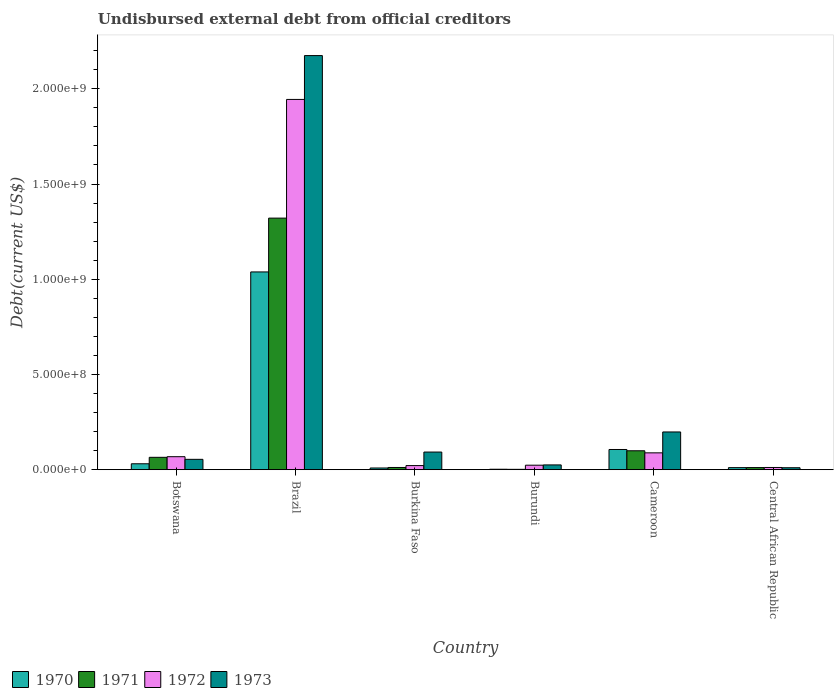How many groups of bars are there?
Offer a very short reply. 6. How many bars are there on the 1st tick from the left?
Give a very brief answer. 4. How many bars are there on the 3rd tick from the right?
Offer a very short reply. 4. What is the label of the 6th group of bars from the left?
Give a very brief answer. Central African Republic. In how many cases, is the number of bars for a given country not equal to the number of legend labels?
Provide a succinct answer. 0. What is the total debt in 1971 in Burundi?
Keep it short and to the point. 1.93e+06. Across all countries, what is the maximum total debt in 1971?
Your response must be concise. 1.32e+09. Across all countries, what is the minimum total debt in 1972?
Give a very brief answer. 1.16e+07. In which country was the total debt in 1971 maximum?
Your response must be concise. Brazil. In which country was the total debt in 1970 minimum?
Offer a very short reply. Burundi. What is the total total debt in 1972 in the graph?
Keep it short and to the point. 2.16e+09. What is the difference between the total debt in 1971 in Brazil and that in Cameroon?
Keep it short and to the point. 1.22e+09. What is the difference between the total debt in 1972 in Central African Republic and the total debt in 1973 in Burundi?
Give a very brief answer. -1.35e+07. What is the average total debt in 1973 per country?
Provide a short and direct response. 4.26e+08. What is the difference between the total debt of/in 1971 and total debt of/in 1973 in Burundi?
Keep it short and to the point. -2.32e+07. What is the ratio of the total debt in 1972 in Burkina Faso to that in Burundi?
Keep it short and to the point. 0.91. What is the difference between the highest and the second highest total debt in 1970?
Your response must be concise. 9.32e+08. What is the difference between the highest and the lowest total debt in 1971?
Your answer should be very brief. 1.32e+09. Is it the case that in every country, the sum of the total debt in 1970 and total debt in 1973 is greater than the sum of total debt in 1971 and total debt in 1972?
Give a very brief answer. No. Is it the case that in every country, the sum of the total debt in 1970 and total debt in 1973 is greater than the total debt in 1972?
Your response must be concise. Yes. How many bars are there?
Provide a succinct answer. 24. What is the difference between two consecutive major ticks on the Y-axis?
Offer a very short reply. 5.00e+08. Are the values on the major ticks of Y-axis written in scientific E-notation?
Your answer should be very brief. Yes. How many legend labels are there?
Give a very brief answer. 4. How are the legend labels stacked?
Provide a succinct answer. Horizontal. What is the title of the graph?
Offer a terse response. Undisbursed external debt from official creditors. Does "2008" appear as one of the legend labels in the graph?
Your response must be concise. No. What is the label or title of the X-axis?
Make the answer very short. Country. What is the label or title of the Y-axis?
Provide a short and direct response. Debt(current US$). What is the Debt(current US$) in 1970 in Botswana?
Provide a short and direct response. 3.11e+07. What is the Debt(current US$) in 1971 in Botswana?
Provide a succinct answer. 6.50e+07. What is the Debt(current US$) in 1972 in Botswana?
Ensure brevity in your answer.  6.83e+07. What is the Debt(current US$) of 1973 in Botswana?
Ensure brevity in your answer.  5.44e+07. What is the Debt(current US$) in 1970 in Brazil?
Provide a succinct answer. 1.04e+09. What is the Debt(current US$) of 1971 in Brazil?
Provide a short and direct response. 1.32e+09. What is the Debt(current US$) in 1972 in Brazil?
Ensure brevity in your answer.  1.94e+09. What is the Debt(current US$) of 1973 in Brazil?
Offer a terse response. 2.17e+09. What is the Debt(current US$) in 1970 in Burkina Faso?
Your answer should be very brief. 8.96e+06. What is the Debt(current US$) in 1971 in Burkina Faso?
Give a very brief answer. 1.16e+07. What is the Debt(current US$) of 1972 in Burkina Faso?
Ensure brevity in your answer.  2.16e+07. What is the Debt(current US$) in 1973 in Burkina Faso?
Provide a succinct answer. 9.26e+07. What is the Debt(current US$) of 1970 in Burundi?
Your answer should be compact. 2.42e+06. What is the Debt(current US$) of 1971 in Burundi?
Your answer should be compact. 1.93e+06. What is the Debt(current US$) in 1972 in Burundi?
Provide a succinct answer. 2.37e+07. What is the Debt(current US$) in 1973 in Burundi?
Ensure brevity in your answer.  2.51e+07. What is the Debt(current US$) in 1970 in Cameroon?
Offer a terse response. 1.06e+08. What is the Debt(current US$) in 1971 in Cameroon?
Give a very brief answer. 9.94e+07. What is the Debt(current US$) of 1972 in Cameroon?
Keep it short and to the point. 8.84e+07. What is the Debt(current US$) in 1973 in Cameroon?
Give a very brief answer. 1.98e+08. What is the Debt(current US$) of 1970 in Central African Republic?
Your answer should be very brief. 1.08e+07. What is the Debt(current US$) in 1971 in Central African Republic?
Ensure brevity in your answer.  1.12e+07. What is the Debt(current US$) of 1972 in Central African Republic?
Your answer should be compact. 1.16e+07. What is the Debt(current US$) of 1973 in Central African Republic?
Give a very brief answer. 1.04e+07. Across all countries, what is the maximum Debt(current US$) of 1970?
Keep it short and to the point. 1.04e+09. Across all countries, what is the maximum Debt(current US$) in 1971?
Offer a terse response. 1.32e+09. Across all countries, what is the maximum Debt(current US$) in 1972?
Give a very brief answer. 1.94e+09. Across all countries, what is the maximum Debt(current US$) of 1973?
Your answer should be very brief. 2.17e+09. Across all countries, what is the minimum Debt(current US$) of 1970?
Make the answer very short. 2.42e+06. Across all countries, what is the minimum Debt(current US$) in 1971?
Provide a succinct answer. 1.93e+06. Across all countries, what is the minimum Debt(current US$) in 1972?
Provide a succinct answer. 1.16e+07. Across all countries, what is the minimum Debt(current US$) of 1973?
Keep it short and to the point. 1.04e+07. What is the total Debt(current US$) of 1970 in the graph?
Your answer should be compact. 1.20e+09. What is the total Debt(current US$) of 1971 in the graph?
Provide a short and direct response. 1.51e+09. What is the total Debt(current US$) in 1972 in the graph?
Keep it short and to the point. 2.16e+09. What is the total Debt(current US$) of 1973 in the graph?
Make the answer very short. 2.55e+09. What is the difference between the Debt(current US$) in 1970 in Botswana and that in Brazil?
Provide a short and direct response. -1.01e+09. What is the difference between the Debt(current US$) of 1971 in Botswana and that in Brazil?
Give a very brief answer. -1.26e+09. What is the difference between the Debt(current US$) of 1972 in Botswana and that in Brazil?
Provide a succinct answer. -1.88e+09. What is the difference between the Debt(current US$) in 1973 in Botswana and that in Brazil?
Offer a very short reply. -2.12e+09. What is the difference between the Debt(current US$) in 1970 in Botswana and that in Burkina Faso?
Your answer should be very brief. 2.21e+07. What is the difference between the Debt(current US$) in 1971 in Botswana and that in Burkina Faso?
Give a very brief answer. 5.34e+07. What is the difference between the Debt(current US$) of 1972 in Botswana and that in Burkina Faso?
Your answer should be very brief. 4.67e+07. What is the difference between the Debt(current US$) of 1973 in Botswana and that in Burkina Faso?
Keep it short and to the point. -3.82e+07. What is the difference between the Debt(current US$) in 1970 in Botswana and that in Burundi?
Offer a terse response. 2.86e+07. What is the difference between the Debt(current US$) in 1971 in Botswana and that in Burundi?
Give a very brief answer. 6.31e+07. What is the difference between the Debt(current US$) in 1972 in Botswana and that in Burundi?
Provide a short and direct response. 4.46e+07. What is the difference between the Debt(current US$) in 1973 in Botswana and that in Burundi?
Keep it short and to the point. 2.93e+07. What is the difference between the Debt(current US$) in 1970 in Botswana and that in Cameroon?
Provide a short and direct response. -7.50e+07. What is the difference between the Debt(current US$) of 1971 in Botswana and that in Cameroon?
Your response must be concise. -3.44e+07. What is the difference between the Debt(current US$) in 1972 in Botswana and that in Cameroon?
Give a very brief answer. -2.02e+07. What is the difference between the Debt(current US$) of 1973 in Botswana and that in Cameroon?
Give a very brief answer. -1.44e+08. What is the difference between the Debt(current US$) of 1970 in Botswana and that in Central African Republic?
Offer a very short reply. 2.02e+07. What is the difference between the Debt(current US$) in 1971 in Botswana and that in Central African Republic?
Your answer should be compact. 5.38e+07. What is the difference between the Debt(current US$) in 1972 in Botswana and that in Central African Republic?
Your answer should be compact. 5.66e+07. What is the difference between the Debt(current US$) of 1973 in Botswana and that in Central African Republic?
Your response must be concise. 4.40e+07. What is the difference between the Debt(current US$) in 1970 in Brazil and that in Burkina Faso?
Your response must be concise. 1.03e+09. What is the difference between the Debt(current US$) in 1971 in Brazil and that in Burkina Faso?
Offer a very short reply. 1.31e+09. What is the difference between the Debt(current US$) of 1972 in Brazil and that in Burkina Faso?
Offer a terse response. 1.92e+09. What is the difference between the Debt(current US$) of 1973 in Brazil and that in Burkina Faso?
Offer a terse response. 2.08e+09. What is the difference between the Debt(current US$) in 1970 in Brazil and that in Burundi?
Your answer should be compact. 1.04e+09. What is the difference between the Debt(current US$) of 1971 in Brazil and that in Burundi?
Provide a succinct answer. 1.32e+09. What is the difference between the Debt(current US$) of 1972 in Brazil and that in Burundi?
Your answer should be compact. 1.92e+09. What is the difference between the Debt(current US$) of 1973 in Brazil and that in Burundi?
Your answer should be very brief. 2.15e+09. What is the difference between the Debt(current US$) of 1970 in Brazil and that in Cameroon?
Offer a very short reply. 9.32e+08. What is the difference between the Debt(current US$) in 1971 in Brazil and that in Cameroon?
Give a very brief answer. 1.22e+09. What is the difference between the Debt(current US$) of 1972 in Brazil and that in Cameroon?
Your answer should be very brief. 1.86e+09. What is the difference between the Debt(current US$) of 1973 in Brazil and that in Cameroon?
Your answer should be compact. 1.98e+09. What is the difference between the Debt(current US$) of 1970 in Brazil and that in Central African Republic?
Make the answer very short. 1.03e+09. What is the difference between the Debt(current US$) of 1971 in Brazil and that in Central African Republic?
Your answer should be very brief. 1.31e+09. What is the difference between the Debt(current US$) of 1972 in Brazil and that in Central African Republic?
Give a very brief answer. 1.93e+09. What is the difference between the Debt(current US$) of 1973 in Brazil and that in Central African Republic?
Your answer should be compact. 2.16e+09. What is the difference between the Debt(current US$) in 1970 in Burkina Faso and that in Burundi?
Offer a very short reply. 6.54e+06. What is the difference between the Debt(current US$) in 1971 in Burkina Faso and that in Burundi?
Your response must be concise. 9.71e+06. What is the difference between the Debt(current US$) in 1972 in Burkina Faso and that in Burundi?
Keep it short and to the point. -2.08e+06. What is the difference between the Debt(current US$) of 1973 in Burkina Faso and that in Burundi?
Your answer should be very brief. 6.75e+07. What is the difference between the Debt(current US$) in 1970 in Burkina Faso and that in Cameroon?
Provide a short and direct response. -9.71e+07. What is the difference between the Debt(current US$) in 1971 in Burkina Faso and that in Cameroon?
Offer a very short reply. -8.77e+07. What is the difference between the Debt(current US$) in 1972 in Burkina Faso and that in Cameroon?
Your answer should be compact. -6.69e+07. What is the difference between the Debt(current US$) of 1973 in Burkina Faso and that in Cameroon?
Provide a succinct answer. -1.06e+08. What is the difference between the Debt(current US$) in 1970 in Burkina Faso and that in Central African Republic?
Keep it short and to the point. -1.89e+06. What is the difference between the Debt(current US$) of 1972 in Burkina Faso and that in Central African Republic?
Ensure brevity in your answer.  9.94e+06. What is the difference between the Debt(current US$) of 1973 in Burkina Faso and that in Central African Republic?
Make the answer very short. 8.22e+07. What is the difference between the Debt(current US$) of 1970 in Burundi and that in Cameroon?
Offer a very short reply. -1.04e+08. What is the difference between the Debt(current US$) in 1971 in Burundi and that in Cameroon?
Provide a succinct answer. -9.74e+07. What is the difference between the Debt(current US$) of 1972 in Burundi and that in Cameroon?
Your answer should be compact. -6.48e+07. What is the difference between the Debt(current US$) of 1973 in Burundi and that in Cameroon?
Offer a terse response. -1.73e+08. What is the difference between the Debt(current US$) in 1970 in Burundi and that in Central African Republic?
Provide a succinct answer. -8.42e+06. What is the difference between the Debt(current US$) in 1971 in Burundi and that in Central African Republic?
Provide a short and direct response. -9.26e+06. What is the difference between the Debt(current US$) in 1972 in Burundi and that in Central African Republic?
Your response must be concise. 1.20e+07. What is the difference between the Debt(current US$) of 1973 in Burundi and that in Central African Republic?
Keep it short and to the point. 1.47e+07. What is the difference between the Debt(current US$) of 1970 in Cameroon and that in Central African Republic?
Offer a very short reply. 9.52e+07. What is the difference between the Debt(current US$) in 1971 in Cameroon and that in Central African Republic?
Offer a terse response. 8.82e+07. What is the difference between the Debt(current US$) of 1972 in Cameroon and that in Central African Republic?
Offer a terse response. 7.68e+07. What is the difference between the Debt(current US$) in 1973 in Cameroon and that in Central African Republic?
Your response must be concise. 1.88e+08. What is the difference between the Debt(current US$) of 1970 in Botswana and the Debt(current US$) of 1971 in Brazil?
Make the answer very short. -1.29e+09. What is the difference between the Debt(current US$) in 1970 in Botswana and the Debt(current US$) in 1972 in Brazil?
Offer a terse response. -1.91e+09. What is the difference between the Debt(current US$) of 1970 in Botswana and the Debt(current US$) of 1973 in Brazil?
Offer a very short reply. -2.14e+09. What is the difference between the Debt(current US$) in 1971 in Botswana and the Debt(current US$) in 1972 in Brazil?
Make the answer very short. -1.88e+09. What is the difference between the Debt(current US$) in 1971 in Botswana and the Debt(current US$) in 1973 in Brazil?
Ensure brevity in your answer.  -2.11e+09. What is the difference between the Debt(current US$) in 1972 in Botswana and the Debt(current US$) in 1973 in Brazil?
Offer a very short reply. -2.11e+09. What is the difference between the Debt(current US$) in 1970 in Botswana and the Debt(current US$) in 1971 in Burkina Faso?
Your answer should be compact. 1.94e+07. What is the difference between the Debt(current US$) in 1970 in Botswana and the Debt(current US$) in 1972 in Burkina Faso?
Your answer should be very brief. 9.50e+06. What is the difference between the Debt(current US$) of 1970 in Botswana and the Debt(current US$) of 1973 in Burkina Faso?
Your answer should be very brief. -6.15e+07. What is the difference between the Debt(current US$) of 1971 in Botswana and the Debt(current US$) of 1972 in Burkina Faso?
Make the answer very short. 4.34e+07. What is the difference between the Debt(current US$) of 1971 in Botswana and the Debt(current US$) of 1973 in Burkina Faso?
Offer a very short reply. -2.76e+07. What is the difference between the Debt(current US$) of 1972 in Botswana and the Debt(current US$) of 1973 in Burkina Faso?
Your response must be concise. -2.43e+07. What is the difference between the Debt(current US$) in 1970 in Botswana and the Debt(current US$) in 1971 in Burundi?
Make the answer very short. 2.91e+07. What is the difference between the Debt(current US$) of 1970 in Botswana and the Debt(current US$) of 1972 in Burundi?
Offer a very short reply. 7.42e+06. What is the difference between the Debt(current US$) in 1970 in Botswana and the Debt(current US$) in 1973 in Burundi?
Offer a terse response. 5.96e+06. What is the difference between the Debt(current US$) in 1971 in Botswana and the Debt(current US$) in 1972 in Burundi?
Your response must be concise. 4.14e+07. What is the difference between the Debt(current US$) of 1971 in Botswana and the Debt(current US$) of 1973 in Burundi?
Offer a terse response. 3.99e+07. What is the difference between the Debt(current US$) in 1972 in Botswana and the Debt(current US$) in 1973 in Burundi?
Give a very brief answer. 4.31e+07. What is the difference between the Debt(current US$) of 1970 in Botswana and the Debt(current US$) of 1971 in Cameroon?
Ensure brevity in your answer.  -6.83e+07. What is the difference between the Debt(current US$) in 1970 in Botswana and the Debt(current US$) in 1972 in Cameroon?
Provide a short and direct response. -5.74e+07. What is the difference between the Debt(current US$) of 1970 in Botswana and the Debt(current US$) of 1973 in Cameroon?
Your response must be concise. -1.67e+08. What is the difference between the Debt(current US$) of 1971 in Botswana and the Debt(current US$) of 1972 in Cameroon?
Your answer should be very brief. -2.34e+07. What is the difference between the Debt(current US$) of 1971 in Botswana and the Debt(current US$) of 1973 in Cameroon?
Provide a succinct answer. -1.33e+08. What is the difference between the Debt(current US$) of 1972 in Botswana and the Debt(current US$) of 1973 in Cameroon?
Give a very brief answer. -1.30e+08. What is the difference between the Debt(current US$) in 1970 in Botswana and the Debt(current US$) in 1971 in Central African Republic?
Keep it short and to the point. 1.99e+07. What is the difference between the Debt(current US$) of 1970 in Botswana and the Debt(current US$) of 1972 in Central African Republic?
Give a very brief answer. 1.94e+07. What is the difference between the Debt(current US$) of 1970 in Botswana and the Debt(current US$) of 1973 in Central African Republic?
Your answer should be compact. 2.07e+07. What is the difference between the Debt(current US$) of 1971 in Botswana and the Debt(current US$) of 1972 in Central African Republic?
Make the answer very short. 5.34e+07. What is the difference between the Debt(current US$) in 1971 in Botswana and the Debt(current US$) in 1973 in Central African Republic?
Provide a short and direct response. 5.46e+07. What is the difference between the Debt(current US$) of 1972 in Botswana and the Debt(current US$) of 1973 in Central African Republic?
Your answer should be compact. 5.79e+07. What is the difference between the Debt(current US$) of 1970 in Brazil and the Debt(current US$) of 1971 in Burkina Faso?
Your answer should be very brief. 1.03e+09. What is the difference between the Debt(current US$) of 1970 in Brazil and the Debt(current US$) of 1972 in Burkina Faso?
Give a very brief answer. 1.02e+09. What is the difference between the Debt(current US$) of 1970 in Brazil and the Debt(current US$) of 1973 in Burkina Faso?
Offer a terse response. 9.46e+08. What is the difference between the Debt(current US$) of 1971 in Brazil and the Debt(current US$) of 1972 in Burkina Faso?
Keep it short and to the point. 1.30e+09. What is the difference between the Debt(current US$) in 1971 in Brazil and the Debt(current US$) in 1973 in Burkina Faso?
Ensure brevity in your answer.  1.23e+09. What is the difference between the Debt(current US$) in 1972 in Brazil and the Debt(current US$) in 1973 in Burkina Faso?
Your response must be concise. 1.85e+09. What is the difference between the Debt(current US$) of 1970 in Brazil and the Debt(current US$) of 1971 in Burundi?
Your response must be concise. 1.04e+09. What is the difference between the Debt(current US$) of 1970 in Brazil and the Debt(current US$) of 1972 in Burundi?
Keep it short and to the point. 1.01e+09. What is the difference between the Debt(current US$) in 1970 in Brazil and the Debt(current US$) in 1973 in Burundi?
Offer a very short reply. 1.01e+09. What is the difference between the Debt(current US$) in 1971 in Brazil and the Debt(current US$) in 1972 in Burundi?
Make the answer very short. 1.30e+09. What is the difference between the Debt(current US$) of 1971 in Brazil and the Debt(current US$) of 1973 in Burundi?
Keep it short and to the point. 1.30e+09. What is the difference between the Debt(current US$) of 1972 in Brazil and the Debt(current US$) of 1973 in Burundi?
Provide a short and direct response. 1.92e+09. What is the difference between the Debt(current US$) of 1970 in Brazil and the Debt(current US$) of 1971 in Cameroon?
Your answer should be very brief. 9.39e+08. What is the difference between the Debt(current US$) in 1970 in Brazil and the Debt(current US$) in 1972 in Cameroon?
Your answer should be compact. 9.50e+08. What is the difference between the Debt(current US$) in 1970 in Brazil and the Debt(current US$) in 1973 in Cameroon?
Your answer should be very brief. 8.40e+08. What is the difference between the Debt(current US$) of 1971 in Brazil and the Debt(current US$) of 1972 in Cameroon?
Give a very brief answer. 1.23e+09. What is the difference between the Debt(current US$) in 1971 in Brazil and the Debt(current US$) in 1973 in Cameroon?
Offer a terse response. 1.12e+09. What is the difference between the Debt(current US$) in 1972 in Brazil and the Debt(current US$) in 1973 in Cameroon?
Give a very brief answer. 1.75e+09. What is the difference between the Debt(current US$) in 1970 in Brazil and the Debt(current US$) in 1971 in Central African Republic?
Your response must be concise. 1.03e+09. What is the difference between the Debt(current US$) of 1970 in Brazil and the Debt(current US$) of 1972 in Central African Republic?
Make the answer very short. 1.03e+09. What is the difference between the Debt(current US$) in 1970 in Brazil and the Debt(current US$) in 1973 in Central African Republic?
Provide a succinct answer. 1.03e+09. What is the difference between the Debt(current US$) of 1971 in Brazil and the Debt(current US$) of 1972 in Central African Republic?
Give a very brief answer. 1.31e+09. What is the difference between the Debt(current US$) in 1971 in Brazil and the Debt(current US$) in 1973 in Central African Republic?
Provide a succinct answer. 1.31e+09. What is the difference between the Debt(current US$) in 1972 in Brazil and the Debt(current US$) in 1973 in Central African Republic?
Your answer should be compact. 1.93e+09. What is the difference between the Debt(current US$) in 1970 in Burkina Faso and the Debt(current US$) in 1971 in Burundi?
Your answer should be compact. 7.03e+06. What is the difference between the Debt(current US$) in 1970 in Burkina Faso and the Debt(current US$) in 1972 in Burundi?
Your response must be concise. -1.47e+07. What is the difference between the Debt(current US$) of 1970 in Burkina Faso and the Debt(current US$) of 1973 in Burundi?
Offer a very short reply. -1.62e+07. What is the difference between the Debt(current US$) of 1971 in Burkina Faso and the Debt(current US$) of 1972 in Burundi?
Provide a short and direct response. -1.20e+07. What is the difference between the Debt(current US$) of 1971 in Burkina Faso and the Debt(current US$) of 1973 in Burundi?
Provide a short and direct response. -1.35e+07. What is the difference between the Debt(current US$) of 1972 in Burkina Faso and the Debt(current US$) of 1973 in Burundi?
Give a very brief answer. -3.53e+06. What is the difference between the Debt(current US$) in 1970 in Burkina Faso and the Debt(current US$) in 1971 in Cameroon?
Ensure brevity in your answer.  -9.04e+07. What is the difference between the Debt(current US$) of 1970 in Burkina Faso and the Debt(current US$) of 1972 in Cameroon?
Your response must be concise. -7.95e+07. What is the difference between the Debt(current US$) in 1970 in Burkina Faso and the Debt(current US$) in 1973 in Cameroon?
Your response must be concise. -1.89e+08. What is the difference between the Debt(current US$) in 1971 in Burkina Faso and the Debt(current US$) in 1972 in Cameroon?
Your answer should be compact. -7.68e+07. What is the difference between the Debt(current US$) in 1971 in Burkina Faso and the Debt(current US$) in 1973 in Cameroon?
Offer a very short reply. -1.87e+08. What is the difference between the Debt(current US$) in 1972 in Burkina Faso and the Debt(current US$) in 1973 in Cameroon?
Your response must be concise. -1.77e+08. What is the difference between the Debt(current US$) of 1970 in Burkina Faso and the Debt(current US$) of 1971 in Central African Republic?
Offer a very short reply. -2.23e+06. What is the difference between the Debt(current US$) in 1970 in Burkina Faso and the Debt(current US$) in 1972 in Central African Republic?
Ensure brevity in your answer.  -2.68e+06. What is the difference between the Debt(current US$) in 1970 in Burkina Faso and the Debt(current US$) in 1973 in Central African Republic?
Ensure brevity in your answer.  -1.41e+06. What is the difference between the Debt(current US$) in 1971 in Burkina Faso and the Debt(current US$) in 1972 in Central African Republic?
Your answer should be very brief. 6000. What is the difference between the Debt(current US$) of 1971 in Burkina Faso and the Debt(current US$) of 1973 in Central African Republic?
Offer a terse response. 1.27e+06. What is the difference between the Debt(current US$) in 1972 in Burkina Faso and the Debt(current US$) in 1973 in Central African Republic?
Your response must be concise. 1.12e+07. What is the difference between the Debt(current US$) in 1970 in Burundi and the Debt(current US$) in 1971 in Cameroon?
Provide a succinct answer. -9.69e+07. What is the difference between the Debt(current US$) of 1970 in Burundi and the Debt(current US$) of 1972 in Cameroon?
Offer a terse response. -8.60e+07. What is the difference between the Debt(current US$) in 1970 in Burundi and the Debt(current US$) in 1973 in Cameroon?
Your answer should be compact. -1.96e+08. What is the difference between the Debt(current US$) of 1971 in Burundi and the Debt(current US$) of 1972 in Cameroon?
Give a very brief answer. -8.65e+07. What is the difference between the Debt(current US$) of 1971 in Burundi and the Debt(current US$) of 1973 in Cameroon?
Offer a very short reply. -1.96e+08. What is the difference between the Debt(current US$) in 1972 in Burundi and the Debt(current US$) in 1973 in Cameroon?
Make the answer very short. -1.75e+08. What is the difference between the Debt(current US$) in 1970 in Burundi and the Debt(current US$) in 1971 in Central African Republic?
Ensure brevity in your answer.  -8.77e+06. What is the difference between the Debt(current US$) of 1970 in Burundi and the Debt(current US$) of 1972 in Central African Republic?
Your answer should be compact. -9.21e+06. What is the difference between the Debt(current US$) in 1970 in Burundi and the Debt(current US$) in 1973 in Central African Republic?
Offer a very short reply. -7.94e+06. What is the difference between the Debt(current US$) of 1971 in Burundi and the Debt(current US$) of 1972 in Central African Republic?
Offer a very short reply. -9.71e+06. What is the difference between the Debt(current US$) in 1971 in Burundi and the Debt(current US$) in 1973 in Central African Republic?
Ensure brevity in your answer.  -8.44e+06. What is the difference between the Debt(current US$) in 1972 in Burundi and the Debt(current US$) in 1973 in Central African Republic?
Make the answer very short. 1.33e+07. What is the difference between the Debt(current US$) of 1970 in Cameroon and the Debt(current US$) of 1971 in Central African Republic?
Provide a succinct answer. 9.49e+07. What is the difference between the Debt(current US$) in 1970 in Cameroon and the Debt(current US$) in 1972 in Central African Republic?
Ensure brevity in your answer.  9.45e+07. What is the difference between the Debt(current US$) of 1970 in Cameroon and the Debt(current US$) of 1973 in Central African Republic?
Keep it short and to the point. 9.57e+07. What is the difference between the Debt(current US$) in 1971 in Cameroon and the Debt(current US$) in 1972 in Central African Republic?
Your answer should be very brief. 8.77e+07. What is the difference between the Debt(current US$) of 1971 in Cameroon and the Debt(current US$) of 1973 in Central African Republic?
Provide a succinct answer. 8.90e+07. What is the difference between the Debt(current US$) of 1972 in Cameroon and the Debt(current US$) of 1973 in Central African Republic?
Give a very brief answer. 7.81e+07. What is the average Debt(current US$) of 1970 per country?
Give a very brief answer. 2.00e+08. What is the average Debt(current US$) in 1971 per country?
Your response must be concise. 2.52e+08. What is the average Debt(current US$) of 1972 per country?
Provide a short and direct response. 3.60e+08. What is the average Debt(current US$) of 1973 per country?
Your response must be concise. 4.26e+08. What is the difference between the Debt(current US$) in 1970 and Debt(current US$) in 1971 in Botswana?
Give a very brief answer. -3.39e+07. What is the difference between the Debt(current US$) in 1970 and Debt(current US$) in 1972 in Botswana?
Provide a short and direct response. -3.72e+07. What is the difference between the Debt(current US$) of 1970 and Debt(current US$) of 1973 in Botswana?
Your answer should be compact. -2.33e+07. What is the difference between the Debt(current US$) in 1971 and Debt(current US$) in 1972 in Botswana?
Keep it short and to the point. -3.24e+06. What is the difference between the Debt(current US$) of 1971 and Debt(current US$) of 1973 in Botswana?
Provide a short and direct response. 1.06e+07. What is the difference between the Debt(current US$) of 1972 and Debt(current US$) of 1973 in Botswana?
Make the answer very short. 1.39e+07. What is the difference between the Debt(current US$) in 1970 and Debt(current US$) in 1971 in Brazil?
Your answer should be very brief. -2.83e+08. What is the difference between the Debt(current US$) of 1970 and Debt(current US$) of 1972 in Brazil?
Your response must be concise. -9.06e+08. What is the difference between the Debt(current US$) of 1970 and Debt(current US$) of 1973 in Brazil?
Offer a terse response. -1.14e+09. What is the difference between the Debt(current US$) in 1971 and Debt(current US$) in 1972 in Brazil?
Your answer should be very brief. -6.23e+08. What is the difference between the Debt(current US$) in 1971 and Debt(current US$) in 1973 in Brazil?
Your answer should be very brief. -8.53e+08. What is the difference between the Debt(current US$) in 1972 and Debt(current US$) in 1973 in Brazil?
Keep it short and to the point. -2.30e+08. What is the difference between the Debt(current US$) of 1970 and Debt(current US$) of 1971 in Burkina Faso?
Ensure brevity in your answer.  -2.68e+06. What is the difference between the Debt(current US$) in 1970 and Debt(current US$) in 1972 in Burkina Faso?
Offer a terse response. -1.26e+07. What is the difference between the Debt(current US$) in 1970 and Debt(current US$) in 1973 in Burkina Faso?
Make the answer very short. -8.36e+07. What is the difference between the Debt(current US$) of 1971 and Debt(current US$) of 1972 in Burkina Faso?
Provide a short and direct response. -9.93e+06. What is the difference between the Debt(current US$) of 1971 and Debt(current US$) of 1973 in Burkina Faso?
Offer a terse response. -8.10e+07. What is the difference between the Debt(current US$) of 1972 and Debt(current US$) of 1973 in Burkina Faso?
Provide a succinct answer. -7.10e+07. What is the difference between the Debt(current US$) of 1970 and Debt(current US$) of 1971 in Burundi?
Give a very brief answer. 4.96e+05. What is the difference between the Debt(current US$) in 1970 and Debt(current US$) in 1972 in Burundi?
Your answer should be compact. -2.12e+07. What is the difference between the Debt(current US$) in 1970 and Debt(current US$) in 1973 in Burundi?
Provide a short and direct response. -2.27e+07. What is the difference between the Debt(current US$) of 1971 and Debt(current US$) of 1972 in Burundi?
Offer a very short reply. -2.17e+07. What is the difference between the Debt(current US$) in 1971 and Debt(current US$) in 1973 in Burundi?
Give a very brief answer. -2.32e+07. What is the difference between the Debt(current US$) in 1972 and Debt(current US$) in 1973 in Burundi?
Offer a terse response. -1.45e+06. What is the difference between the Debt(current US$) in 1970 and Debt(current US$) in 1971 in Cameroon?
Your answer should be very brief. 6.72e+06. What is the difference between the Debt(current US$) in 1970 and Debt(current US$) in 1972 in Cameroon?
Your answer should be compact. 1.76e+07. What is the difference between the Debt(current US$) of 1970 and Debt(current US$) of 1973 in Cameroon?
Make the answer very short. -9.21e+07. What is the difference between the Debt(current US$) in 1971 and Debt(current US$) in 1972 in Cameroon?
Make the answer very short. 1.09e+07. What is the difference between the Debt(current US$) in 1971 and Debt(current US$) in 1973 in Cameroon?
Your answer should be compact. -9.88e+07. What is the difference between the Debt(current US$) of 1972 and Debt(current US$) of 1973 in Cameroon?
Offer a terse response. -1.10e+08. What is the difference between the Debt(current US$) of 1970 and Debt(current US$) of 1971 in Central African Republic?
Keep it short and to the point. -3.44e+05. What is the difference between the Debt(current US$) in 1970 and Debt(current US$) in 1972 in Central African Republic?
Make the answer very short. -7.88e+05. What is the difference between the Debt(current US$) in 1971 and Debt(current US$) in 1972 in Central African Republic?
Your answer should be compact. -4.44e+05. What is the difference between the Debt(current US$) in 1971 and Debt(current US$) in 1973 in Central African Republic?
Your answer should be very brief. 8.24e+05. What is the difference between the Debt(current US$) of 1972 and Debt(current US$) of 1973 in Central African Republic?
Offer a terse response. 1.27e+06. What is the ratio of the Debt(current US$) in 1970 in Botswana to that in Brazil?
Make the answer very short. 0.03. What is the ratio of the Debt(current US$) in 1971 in Botswana to that in Brazil?
Your response must be concise. 0.05. What is the ratio of the Debt(current US$) of 1972 in Botswana to that in Brazil?
Provide a short and direct response. 0.04. What is the ratio of the Debt(current US$) in 1973 in Botswana to that in Brazil?
Your answer should be very brief. 0.03. What is the ratio of the Debt(current US$) in 1970 in Botswana to that in Burkina Faso?
Ensure brevity in your answer.  3.47. What is the ratio of the Debt(current US$) in 1971 in Botswana to that in Burkina Faso?
Offer a terse response. 5.58. What is the ratio of the Debt(current US$) in 1972 in Botswana to that in Burkina Faso?
Give a very brief answer. 3.16. What is the ratio of the Debt(current US$) in 1973 in Botswana to that in Burkina Faso?
Your answer should be compact. 0.59. What is the ratio of the Debt(current US$) in 1970 in Botswana to that in Burundi?
Keep it short and to the point. 12.81. What is the ratio of the Debt(current US$) in 1971 in Botswana to that in Burundi?
Provide a succinct answer. 33.7. What is the ratio of the Debt(current US$) in 1972 in Botswana to that in Burundi?
Ensure brevity in your answer.  2.89. What is the ratio of the Debt(current US$) of 1973 in Botswana to that in Burundi?
Offer a terse response. 2.17. What is the ratio of the Debt(current US$) in 1970 in Botswana to that in Cameroon?
Give a very brief answer. 0.29. What is the ratio of the Debt(current US$) of 1971 in Botswana to that in Cameroon?
Offer a very short reply. 0.65. What is the ratio of the Debt(current US$) in 1972 in Botswana to that in Cameroon?
Make the answer very short. 0.77. What is the ratio of the Debt(current US$) in 1973 in Botswana to that in Cameroon?
Your response must be concise. 0.27. What is the ratio of the Debt(current US$) in 1970 in Botswana to that in Central African Republic?
Make the answer very short. 2.86. What is the ratio of the Debt(current US$) in 1971 in Botswana to that in Central African Republic?
Your response must be concise. 5.81. What is the ratio of the Debt(current US$) in 1972 in Botswana to that in Central African Republic?
Provide a succinct answer. 5.87. What is the ratio of the Debt(current US$) in 1973 in Botswana to that in Central African Republic?
Ensure brevity in your answer.  5.24. What is the ratio of the Debt(current US$) of 1970 in Brazil to that in Burkina Faso?
Your answer should be compact. 115.89. What is the ratio of the Debt(current US$) of 1971 in Brazil to that in Burkina Faso?
Keep it short and to the point. 113.46. What is the ratio of the Debt(current US$) in 1972 in Brazil to that in Burkina Faso?
Your answer should be very brief. 90.11. What is the ratio of the Debt(current US$) of 1973 in Brazil to that in Burkina Faso?
Your response must be concise. 23.48. What is the ratio of the Debt(current US$) in 1970 in Brazil to that in Burundi?
Your answer should be very brief. 428.19. What is the ratio of the Debt(current US$) of 1971 in Brazil to that in Burundi?
Provide a succinct answer. 684.77. What is the ratio of the Debt(current US$) of 1972 in Brazil to that in Burundi?
Provide a short and direct response. 82.18. What is the ratio of the Debt(current US$) in 1973 in Brazil to that in Burundi?
Your answer should be compact. 86.59. What is the ratio of the Debt(current US$) of 1970 in Brazil to that in Cameroon?
Your answer should be compact. 9.79. What is the ratio of the Debt(current US$) of 1971 in Brazil to that in Cameroon?
Ensure brevity in your answer.  13.29. What is the ratio of the Debt(current US$) in 1972 in Brazil to that in Cameroon?
Ensure brevity in your answer.  21.98. What is the ratio of the Debt(current US$) of 1973 in Brazil to that in Cameroon?
Your answer should be very brief. 10.97. What is the ratio of the Debt(current US$) in 1970 in Brazil to that in Central African Republic?
Ensure brevity in your answer.  95.72. What is the ratio of the Debt(current US$) of 1971 in Brazil to that in Central African Republic?
Offer a terse response. 118.02. What is the ratio of the Debt(current US$) of 1972 in Brazil to that in Central African Republic?
Your answer should be very brief. 167.08. What is the ratio of the Debt(current US$) of 1973 in Brazil to that in Central African Republic?
Your response must be concise. 209.72. What is the ratio of the Debt(current US$) of 1970 in Burkina Faso to that in Burundi?
Your answer should be very brief. 3.69. What is the ratio of the Debt(current US$) of 1971 in Burkina Faso to that in Burundi?
Your response must be concise. 6.04. What is the ratio of the Debt(current US$) of 1972 in Burkina Faso to that in Burundi?
Give a very brief answer. 0.91. What is the ratio of the Debt(current US$) of 1973 in Burkina Faso to that in Burundi?
Provide a short and direct response. 3.69. What is the ratio of the Debt(current US$) in 1970 in Burkina Faso to that in Cameroon?
Your answer should be compact. 0.08. What is the ratio of the Debt(current US$) of 1971 in Burkina Faso to that in Cameroon?
Your answer should be very brief. 0.12. What is the ratio of the Debt(current US$) in 1972 in Burkina Faso to that in Cameroon?
Make the answer very short. 0.24. What is the ratio of the Debt(current US$) in 1973 in Burkina Faso to that in Cameroon?
Provide a succinct answer. 0.47. What is the ratio of the Debt(current US$) of 1970 in Burkina Faso to that in Central African Republic?
Your answer should be very brief. 0.83. What is the ratio of the Debt(current US$) of 1971 in Burkina Faso to that in Central African Republic?
Ensure brevity in your answer.  1.04. What is the ratio of the Debt(current US$) in 1972 in Burkina Faso to that in Central African Republic?
Make the answer very short. 1.85. What is the ratio of the Debt(current US$) of 1973 in Burkina Faso to that in Central African Republic?
Your answer should be compact. 8.93. What is the ratio of the Debt(current US$) in 1970 in Burundi to that in Cameroon?
Offer a terse response. 0.02. What is the ratio of the Debt(current US$) of 1971 in Burundi to that in Cameroon?
Give a very brief answer. 0.02. What is the ratio of the Debt(current US$) in 1972 in Burundi to that in Cameroon?
Make the answer very short. 0.27. What is the ratio of the Debt(current US$) in 1973 in Burundi to that in Cameroon?
Your answer should be very brief. 0.13. What is the ratio of the Debt(current US$) in 1970 in Burundi to that in Central African Republic?
Your answer should be compact. 0.22. What is the ratio of the Debt(current US$) in 1971 in Burundi to that in Central African Republic?
Ensure brevity in your answer.  0.17. What is the ratio of the Debt(current US$) in 1972 in Burundi to that in Central African Republic?
Offer a very short reply. 2.03. What is the ratio of the Debt(current US$) of 1973 in Burundi to that in Central African Republic?
Your response must be concise. 2.42. What is the ratio of the Debt(current US$) of 1970 in Cameroon to that in Central African Republic?
Give a very brief answer. 9.78. What is the ratio of the Debt(current US$) of 1971 in Cameroon to that in Central African Republic?
Keep it short and to the point. 8.88. What is the ratio of the Debt(current US$) in 1972 in Cameroon to that in Central African Republic?
Your answer should be compact. 7.6. What is the ratio of the Debt(current US$) in 1973 in Cameroon to that in Central African Republic?
Ensure brevity in your answer.  19.11. What is the difference between the highest and the second highest Debt(current US$) in 1970?
Give a very brief answer. 9.32e+08. What is the difference between the highest and the second highest Debt(current US$) of 1971?
Your answer should be compact. 1.22e+09. What is the difference between the highest and the second highest Debt(current US$) of 1972?
Offer a terse response. 1.86e+09. What is the difference between the highest and the second highest Debt(current US$) in 1973?
Make the answer very short. 1.98e+09. What is the difference between the highest and the lowest Debt(current US$) in 1970?
Your answer should be very brief. 1.04e+09. What is the difference between the highest and the lowest Debt(current US$) in 1971?
Your answer should be very brief. 1.32e+09. What is the difference between the highest and the lowest Debt(current US$) in 1972?
Your answer should be compact. 1.93e+09. What is the difference between the highest and the lowest Debt(current US$) of 1973?
Provide a short and direct response. 2.16e+09. 